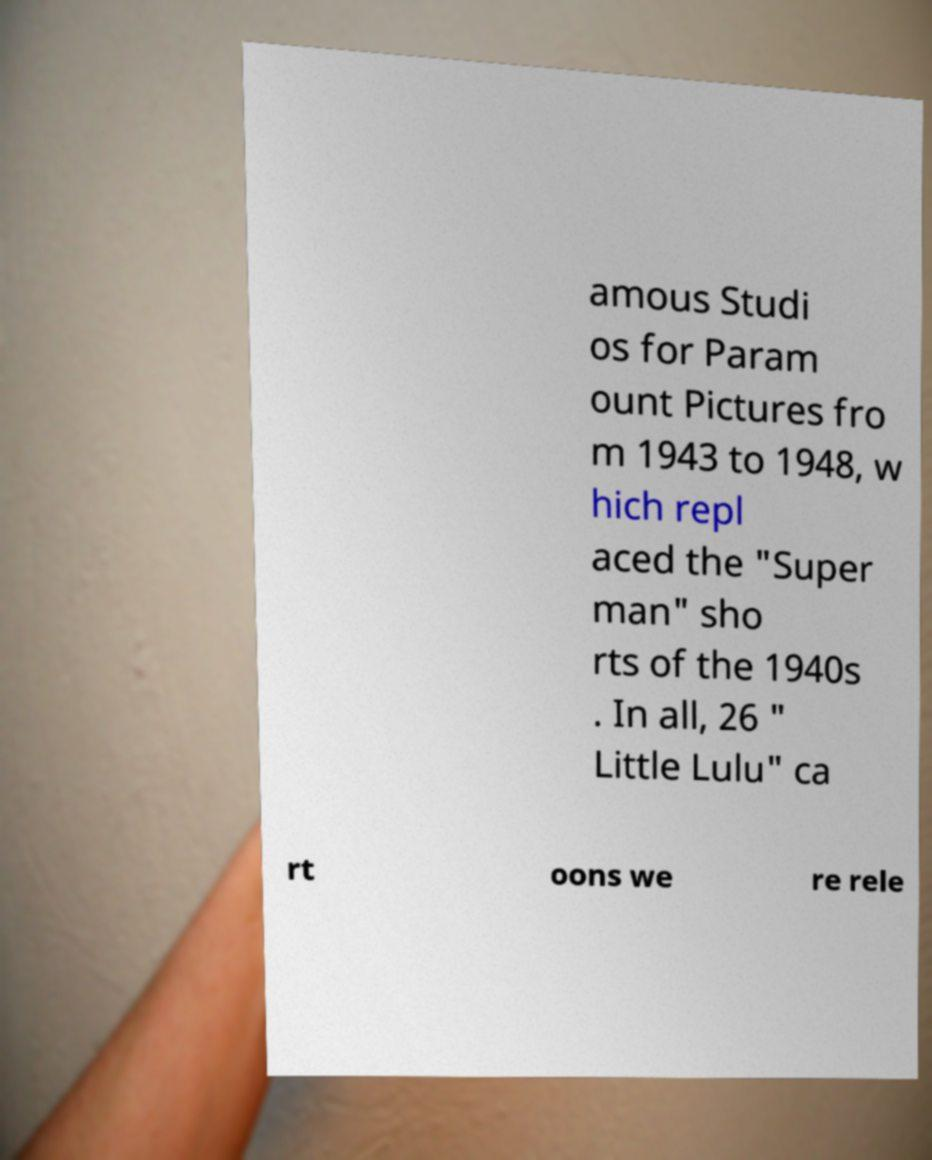Could you extract and type out the text from this image? amous Studi os for Param ount Pictures fro m 1943 to 1948, w hich repl aced the "Super man" sho rts of the 1940s . In all, 26 " Little Lulu" ca rt oons we re rele 